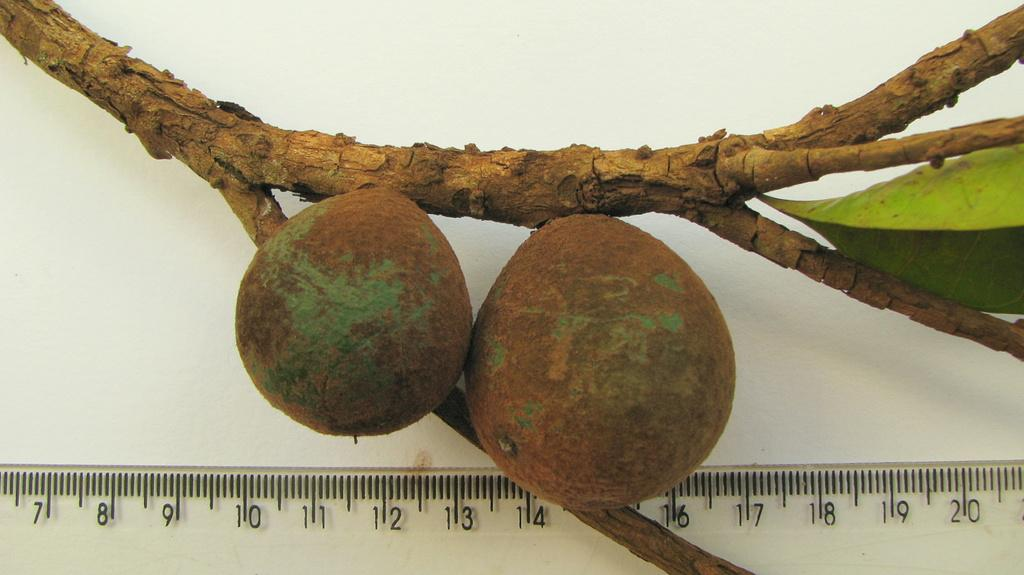What is depicted on the stem in the image? There are two fruits and a leaf on the stem in the image. What object is present for measuring weight in the image? There is a scale with readings in the image. What type of record is being played on the scale in the image? There is no record or music player present in the image; it only features a scale and a stem with fruits. Can you see a goose near the scale in the image? There is no goose present in the image. 